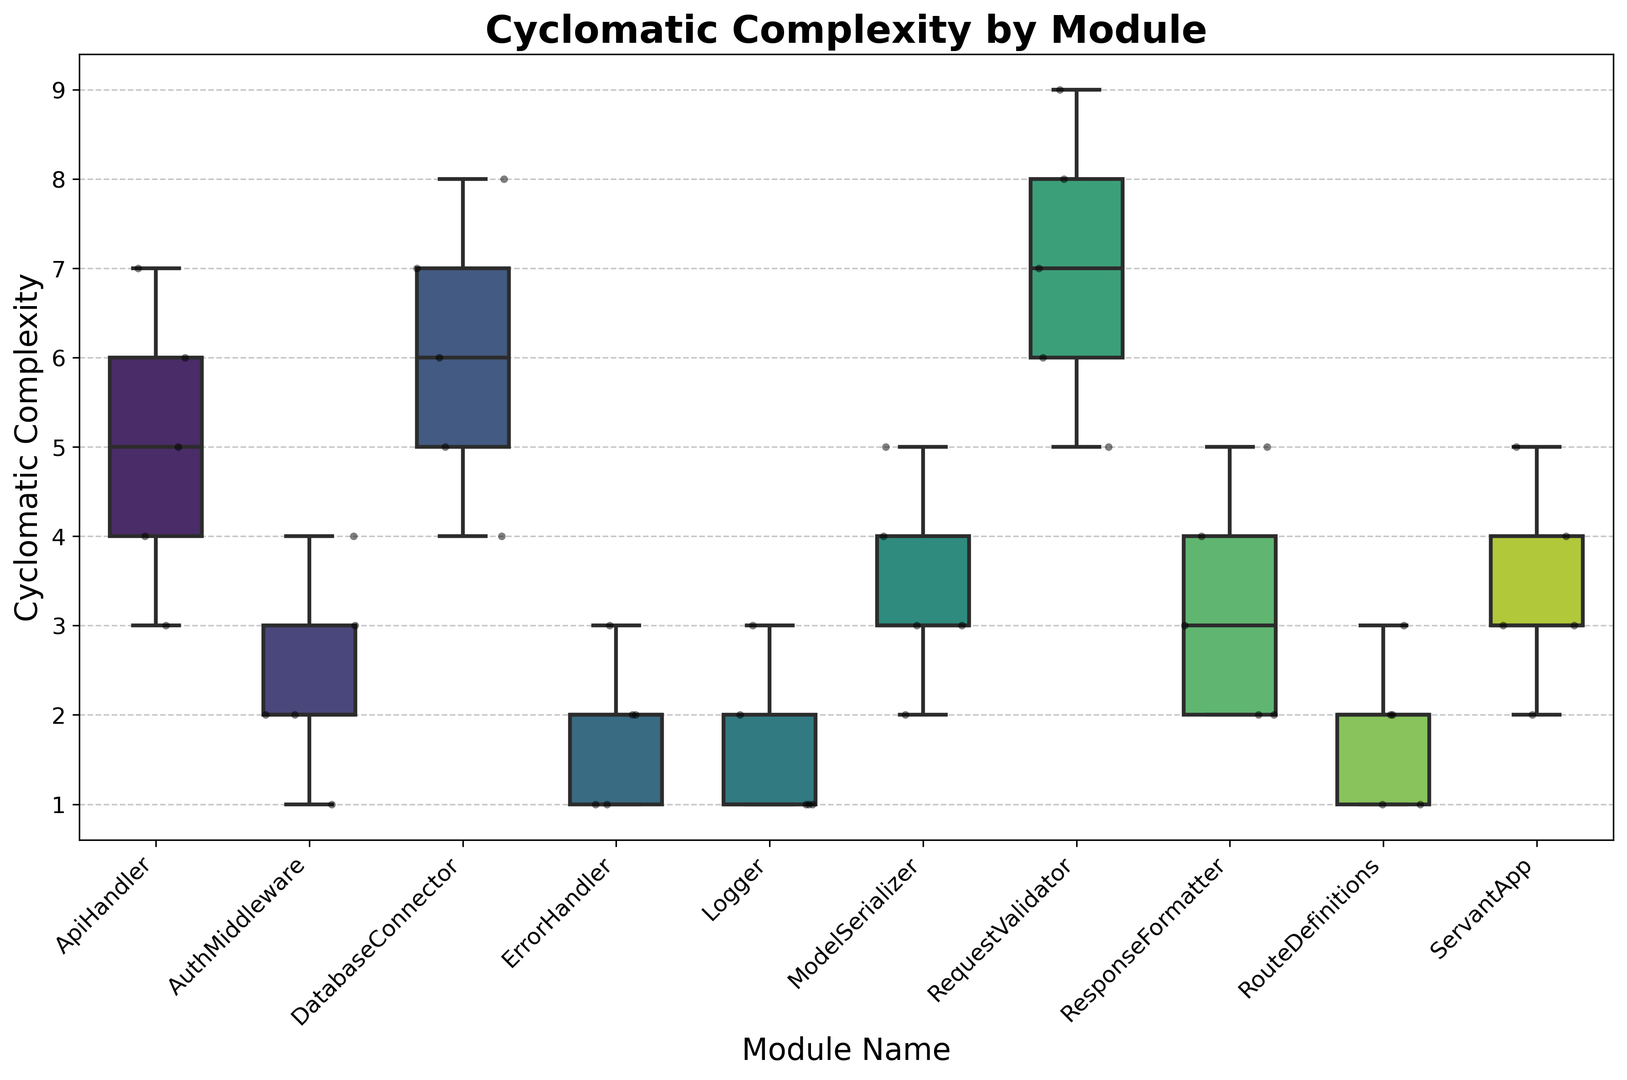What module has the highest median cyclomatic complexity? We look at the vertical line inside each box plot, which indicates the median. Comparing all boxes, the "RequestValidator" module has the highest median, indicated by the vertical line positioned higher compared to others.
Answer: RequestValidator Which module shows the widest range of cyclomatic complexity values? The range of values is given by the difference in the positions of the top whisker and the bottom whisker of the box plot. Comparing all modules, the "RequestValidator" module has the widest range.
Answer: RequestValidator How many modules have a median cyclomatic complexity below 3? By observing the vertical lines in the box plots, we note those positioned below the value of 3 on the y-axis. There are 5 such modules: "AuthMiddleware", "ErrorHandler", "Logger", "RouteDefinitions", and "ServantApp".
Answer: 5 Which module has the smallest interquartile range (IQR) of cyclomatic complexity? The IQR is shown by the height of the box in the box plot. By comparing all modules, the "Logger" module has the smallest box indicating the smallest IQR.
Answer: Logger Is the median cyclomatic complexity of the "ApiHandler" module greater than that of the "DatabaseConnector" module? Comparing the median lines of the "ApiHandler" and "DatabaseConnector" modules, the "ApiHandler" has a median line at 5 while "DatabaseConnector" is also at 5. Thus, they are equal.
Answer: No Which modules have outlier values for cyclomatic complexity? Outliers are indicated by individual points outside the whiskers of the box plots. None of the modules display any outliers, as there are no points outside the whiskers.
Answer: None Does the "ModelSerializer" module have a lower quartile (25th percentile) higher than the upper quartile (75th percentile) of the "ErrorHandler" module? The lower quartile (bottom of the box) for "ModelSerializer" is around 3, while the upper quartile (top of the box) for "ErrorHandler" is around 2.5. Thus, the lower quartile of "ModelSerializer" is indeed higher.
Answer: Yes What is the difference in medians between the "ServantApp" and "RouteDefinitions" modules? The median of "ServantApp" is around 3, and the median of "RouteDefinitions" is around 2. Thus, the difference in medians is 3 - 2 = 1.
Answer: 1 Which modules have their entire interquartile range (IQR) within the same bounds (1 to 3)? The IQR is the box part of the box plot. Both "Logger" and "RouteDefinitions" have their entire boxes (IQRs) within the range 1 to 3.
Answer: Logger, RouteDefinitions 